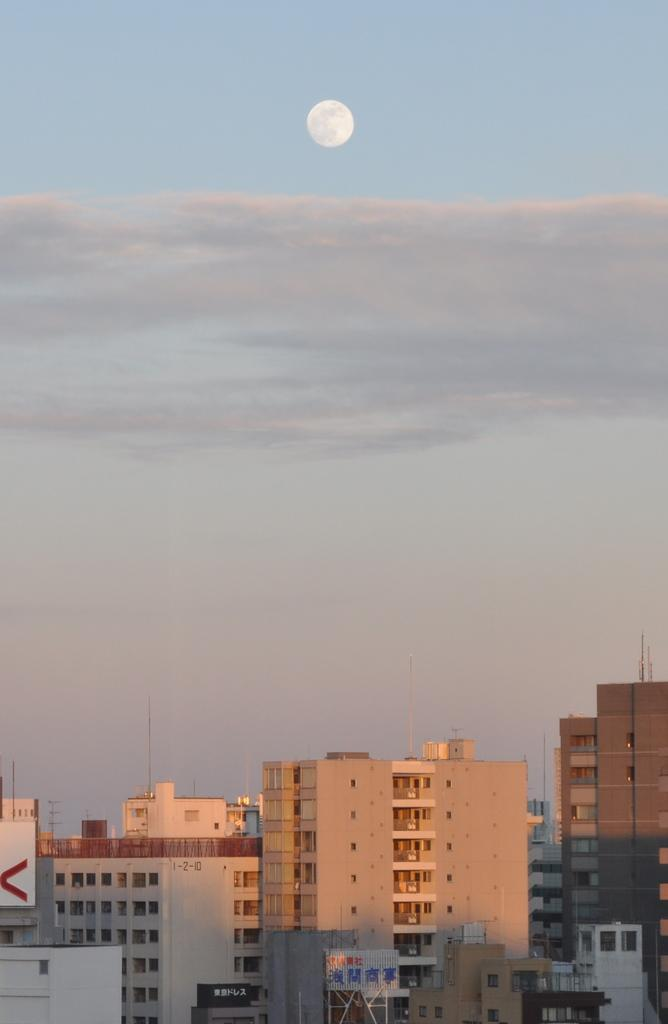What types of structures are located at the bottom of the image? There are buildings and houses at the bottom of the image. What else can be seen at the bottom of the image? There are poles at the bottom of the image. What is visible at the top of the image? The sky is visible at the top of the image. Can the sun be seen in the sky? Yes, the sun is observable in the sky. Where are the ants carrying the meat in the image? There are no ants or meat present in the image. Can you tell me the total cost of the items on the receipt in the image? There is no receipt present in the image. 